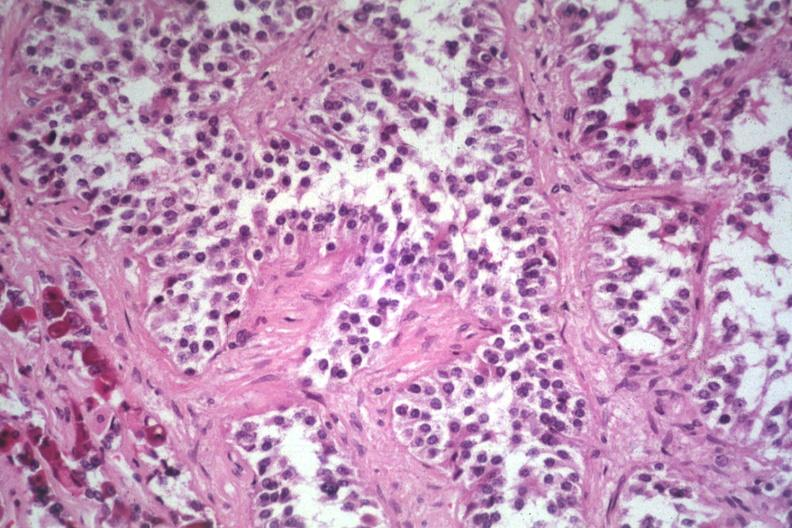what does this image show?
Answer the question using a single word or phrase. Papillary lesion unusual 